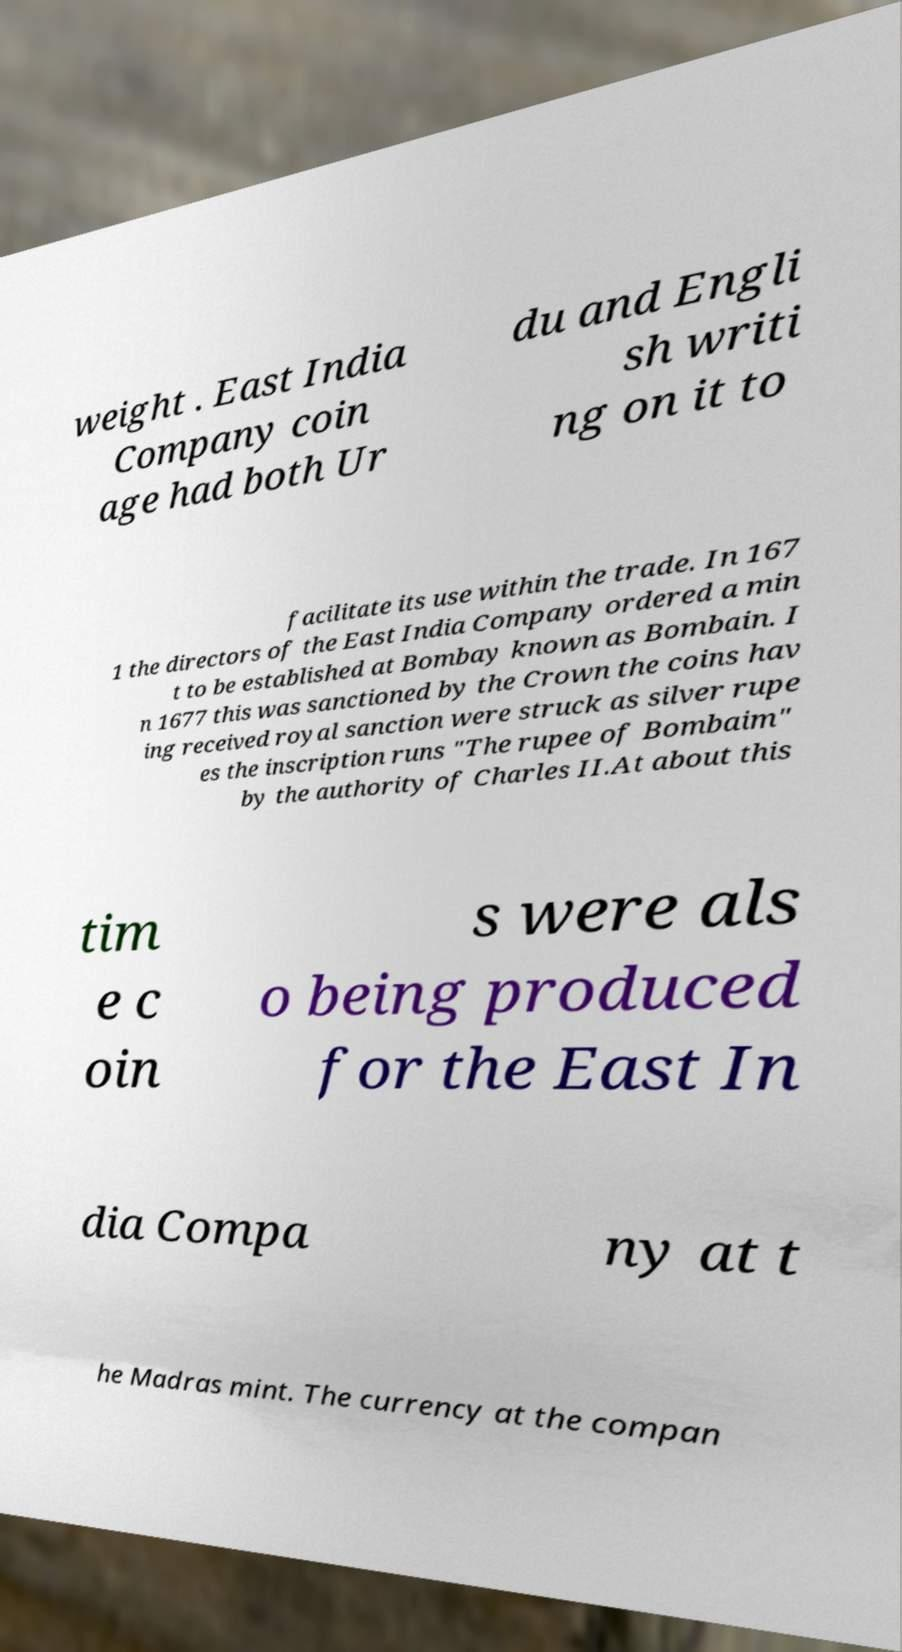What messages or text are displayed in this image? I need them in a readable, typed format. weight . East India Company coin age had both Ur du and Engli sh writi ng on it to facilitate its use within the trade. In 167 1 the directors of the East India Company ordered a min t to be established at Bombay known as Bombain. I n 1677 this was sanctioned by the Crown the coins hav ing received royal sanction were struck as silver rupe es the inscription runs "The rupee of Bombaim" by the authority of Charles II.At about this tim e c oin s were als o being produced for the East In dia Compa ny at t he Madras mint. The currency at the compan 